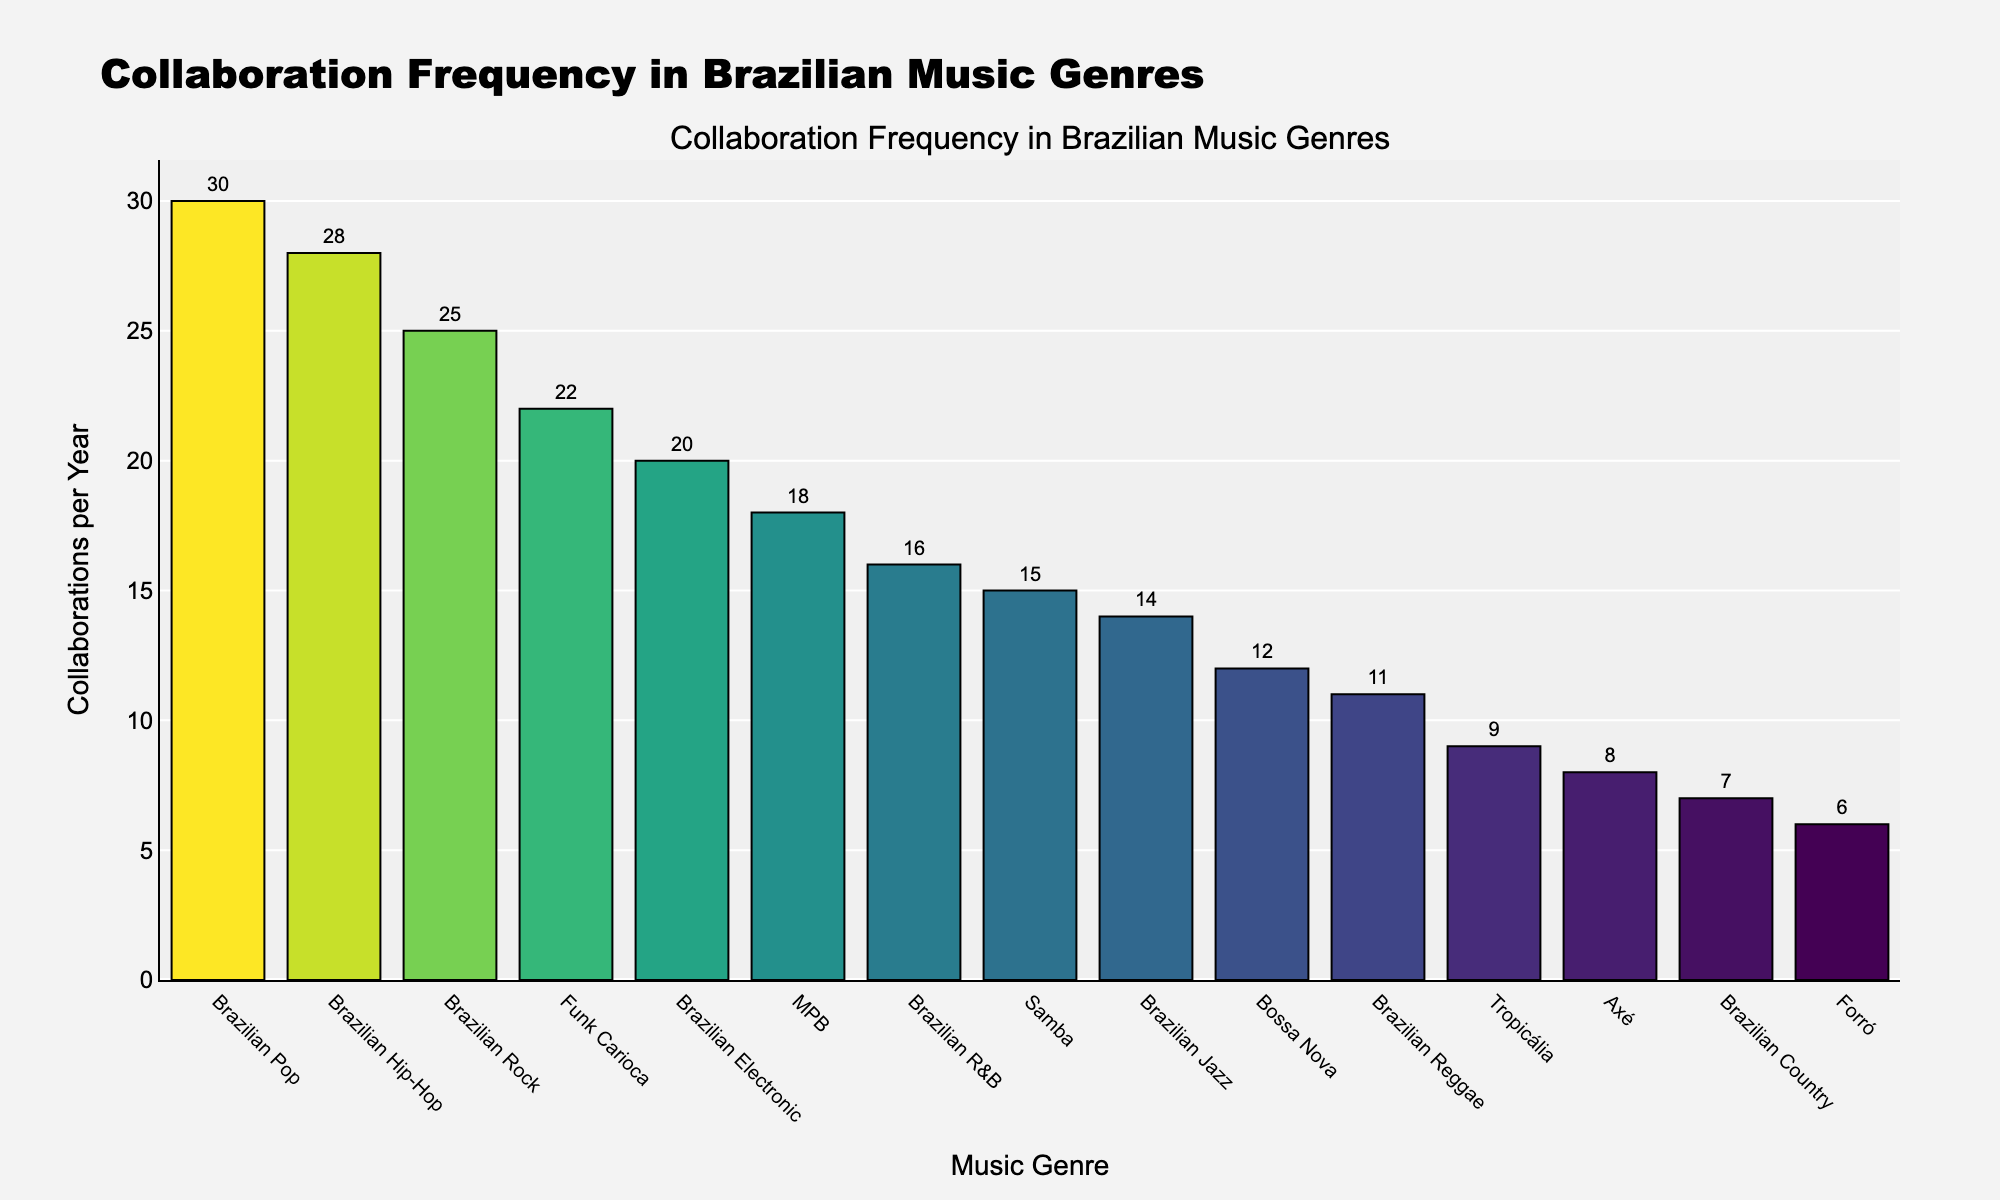What's the music genre with the highest collaboration frequency? To find the genre with the highest collaboration frequency, look for the tallest bar in the chart. The genre at the top is Brazilian Pop, indicating the highest number of collaborations per year.
Answer: Brazilian Pop How many more collaborations does Funk Carioca have compared to Forró per year? To determine this, find the bars corresponding to Funk Carioca and Forró. Funk Carioca has 22 collaborations, and Forró has 6. Calculate the difference: 22 - 6 = 16.
Answer: 16 What's the sum of collaborations per year for Brazilian Rock and Brazilian R&B? To solve this, locate the bars for Brazilian Rock and Brazilian R&B. Brazilian Rock has 25 collaborations, and Brazilian R&B has 16. Add these values together: 25 + 16 = 41.
Answer: 41 Which genres have more than 20 collaborations per year? Identify the bars that extend beyond the 20-collaborations mark. The genres with more than 20 collaborations are Funk Carioca, Brazilian Rock, Brazilian Pop, and Brazilian Hip-Hop.
Answer: Funk Carioca, Brazilian Rock, Brazilian Pop, Brazilian Hip-Hop What's the average number of collaborations per year across all genres? To calculate the average, find the total sum of collaborations and the number of genres. Sum all collaborations (15 + 12 + 18 + 22 + 8 + 6 + 9 + 25 + 30 + 28 + 20 + 14 + 11 + 7 + 16 = 241) and divide by the 15 genres: 241/15 ≈ 16.07.
Answer: 16.07 How many genres have fewer than 10 collaborations per year? Count the bars that are shorter than the 10-collaborations mark. The genres with fewer than 10 collaborations are Axé, Forró, Tropicália, and Brazilian Country.
Answer: 4 Which genre is closest to the median collaboration frequency? First, list the number of collaborations in ascending order: (6, 7, 8, 9, 11, 12, 14, 15, 16, 18, 20, 22, 25, 28, 30). With 15 values, the median is the 8th value: 15. The genre closest to this is Samba.
Answer: Samba 